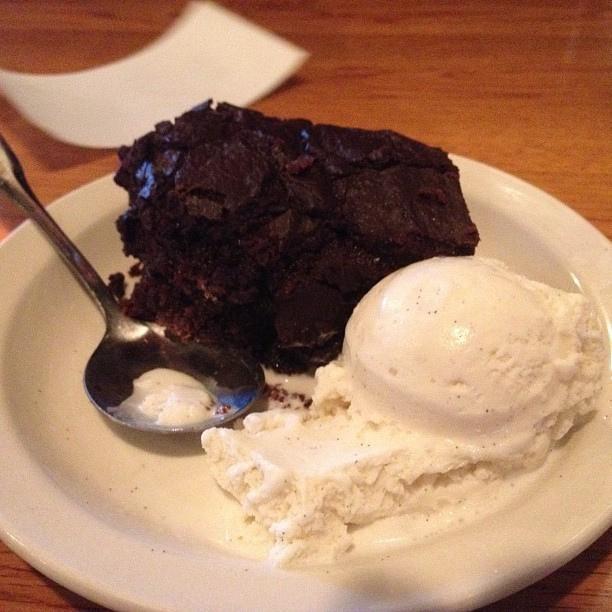How many cakes are there?
Give a very brief answer. 2. 